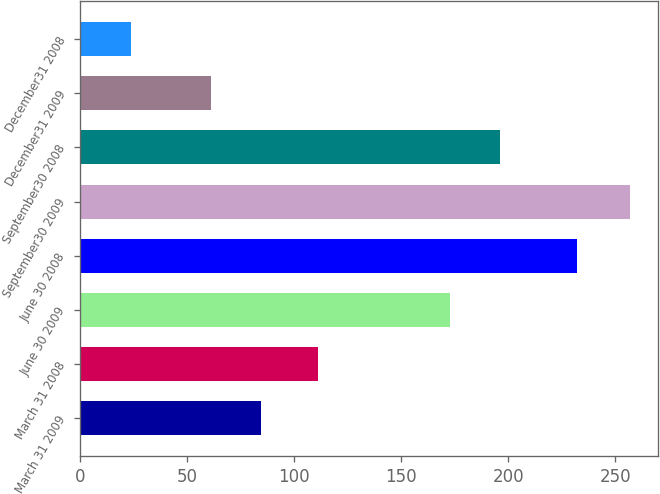Convert chart to OTSL. <chart><loc_0><loc_0><loc_500><loc_500><bar_chart><fcel>March 31 2009<fcel>March 31 2008<fcel>June 30 2009<fcel>June 30 2008<fcel>September30 2009<fcel>September30 2008<fcel>December31 2009<fcel>December31 2008<nl><fcel>84.3<fcel>111<fcel>173<fcel>232<fcel>257<fcel>196.3<fcel>61<fcel>24<nl></chart> 